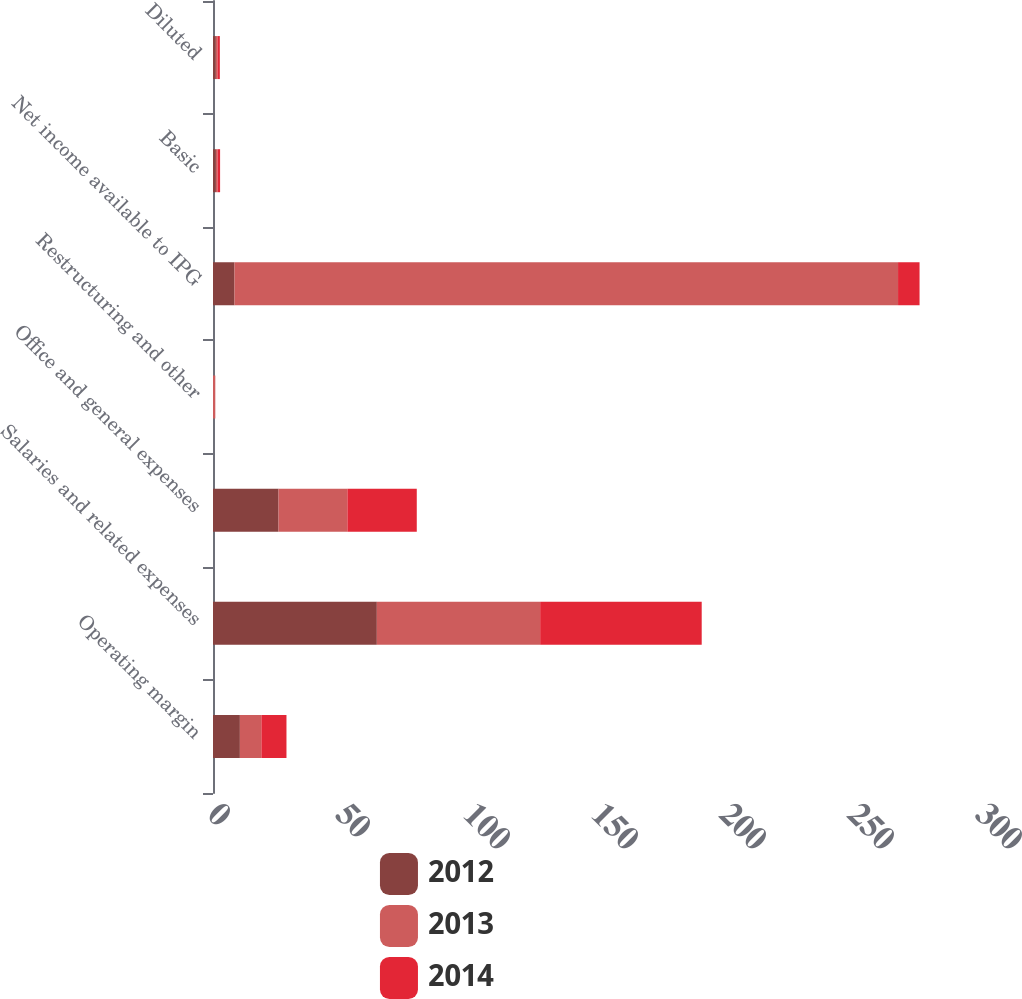Convert chart. <chart><loc_0><loc_0><loc_500><loc_500><stacked_bar_chart><ecel><fcel>Operating margin<fcel>Salaries and related expenses<fcel>Office and general expenses<fcel>Restructuring and other<fcel>Net income available to IPG<fcel>Basic<fcel>Diluted<nl><fcel>2012<fcel>10.5<fcel>64<fcel>25.6<fcel>0<fcel>8.4<fcel>1.14<fcel>1.12<nl><fcel>2013<fcel>8.4<fcel>63.8<fcel>26.9<fcel>0.9<fcel>259.2<fcel>0.62<fcel>0.61<nl><fcel>2014<fcel>9.8<fcel>63.1<fcel>27.1<fcel>0<fcel>8.4<fcel>1.01<fcel>0.94<nl></chart> 